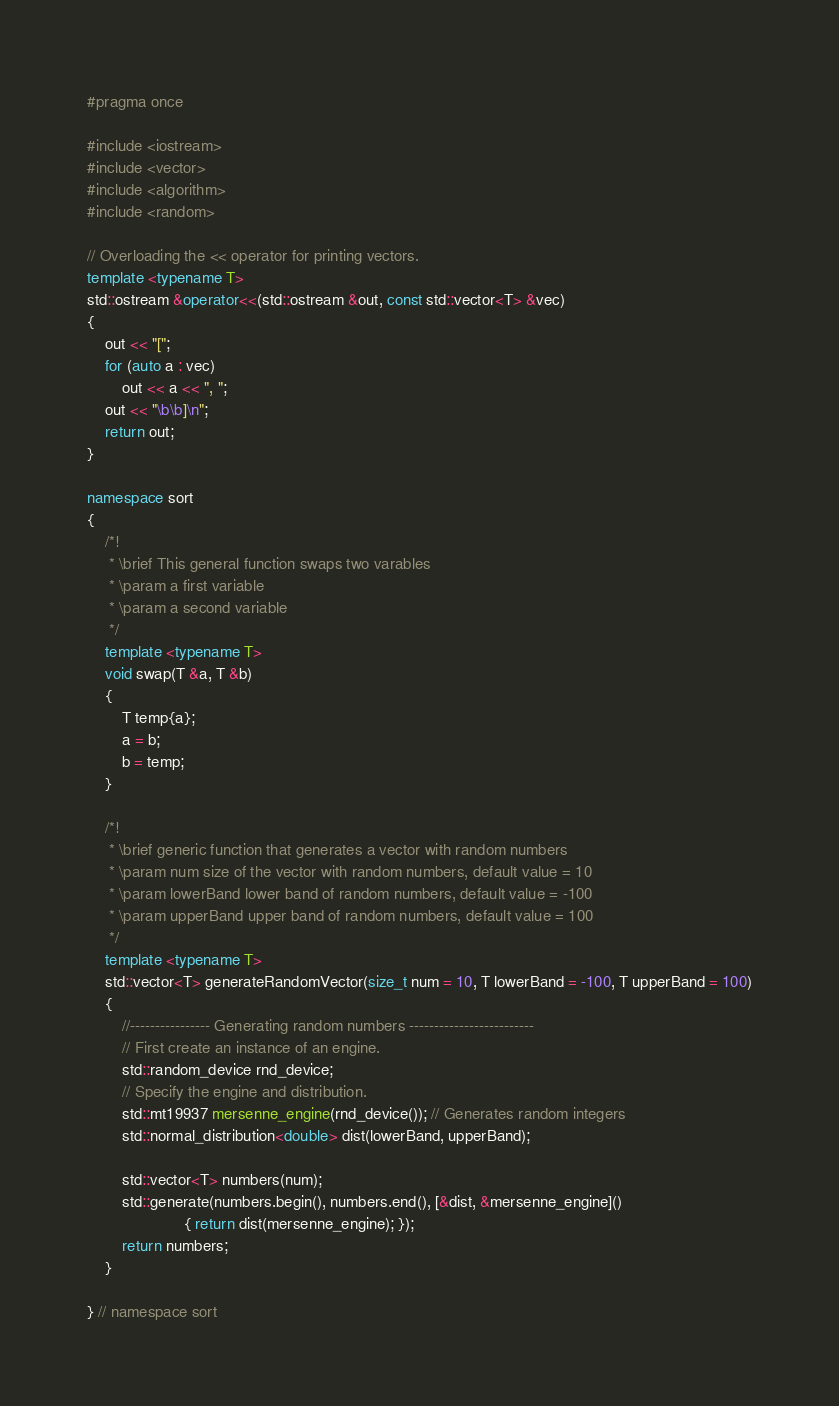Convert code to text. <code><loc_0><loc_0><loc_500><loc_500><_C++_>#pragma once

#include <iostream>
#include <vector>
#include <algorithm>
#include <random>

// Overloading the << operator for printing vectors.
template <typename T>
std::ostream &operator<<(std::ostream &out, const std::vector<T> &vec)
{
    out << "[";
    for (auto a : vec)
        out << a << ", ";
    out << "\b\b]\n";
    return out;
}

namespace sort
{
    /*!
     * \brief This general function swaps two varables
     * \param a first variable
     * \param a second variable
     */
    template <typename T>
    void swap(T &a, T &b)
    {
        T temp{a};
        a = b;
        b = temp;
    }

    /*!
     * \brief generic function that generates a vector with random numbers
     * \param num size of the vector with random numbers, default value = 10
     * \param lowerBand lower band of random numbers, default value = -100
     * \param upperBand upper band of random numbers, default value = 100
     */
    template <typename T>
    std::vector<T> generateRandomVector(size_t num = 10, T lowerBand = -100, T upperBand = 100)
    {
        //---------------- Generating random numbers -------------------------
        // First create an instance of an engine.
        std::random_device rnd_device;
        // Specify the engine and distribution.
        std::mt19937 mersenne_engine(rnd_device()); // Generates random integers
        std::normal_distribution<double> dist(lowerBand, upperBand);

        std::vector<T> numbers(num);
        std::generate(numbers.begin(), numbers.end(), [&dist, &mersenne_engine]()
                      { return dist(mersenne_engine); });
        return numbers;
    }

} // namespace sort
</code> 